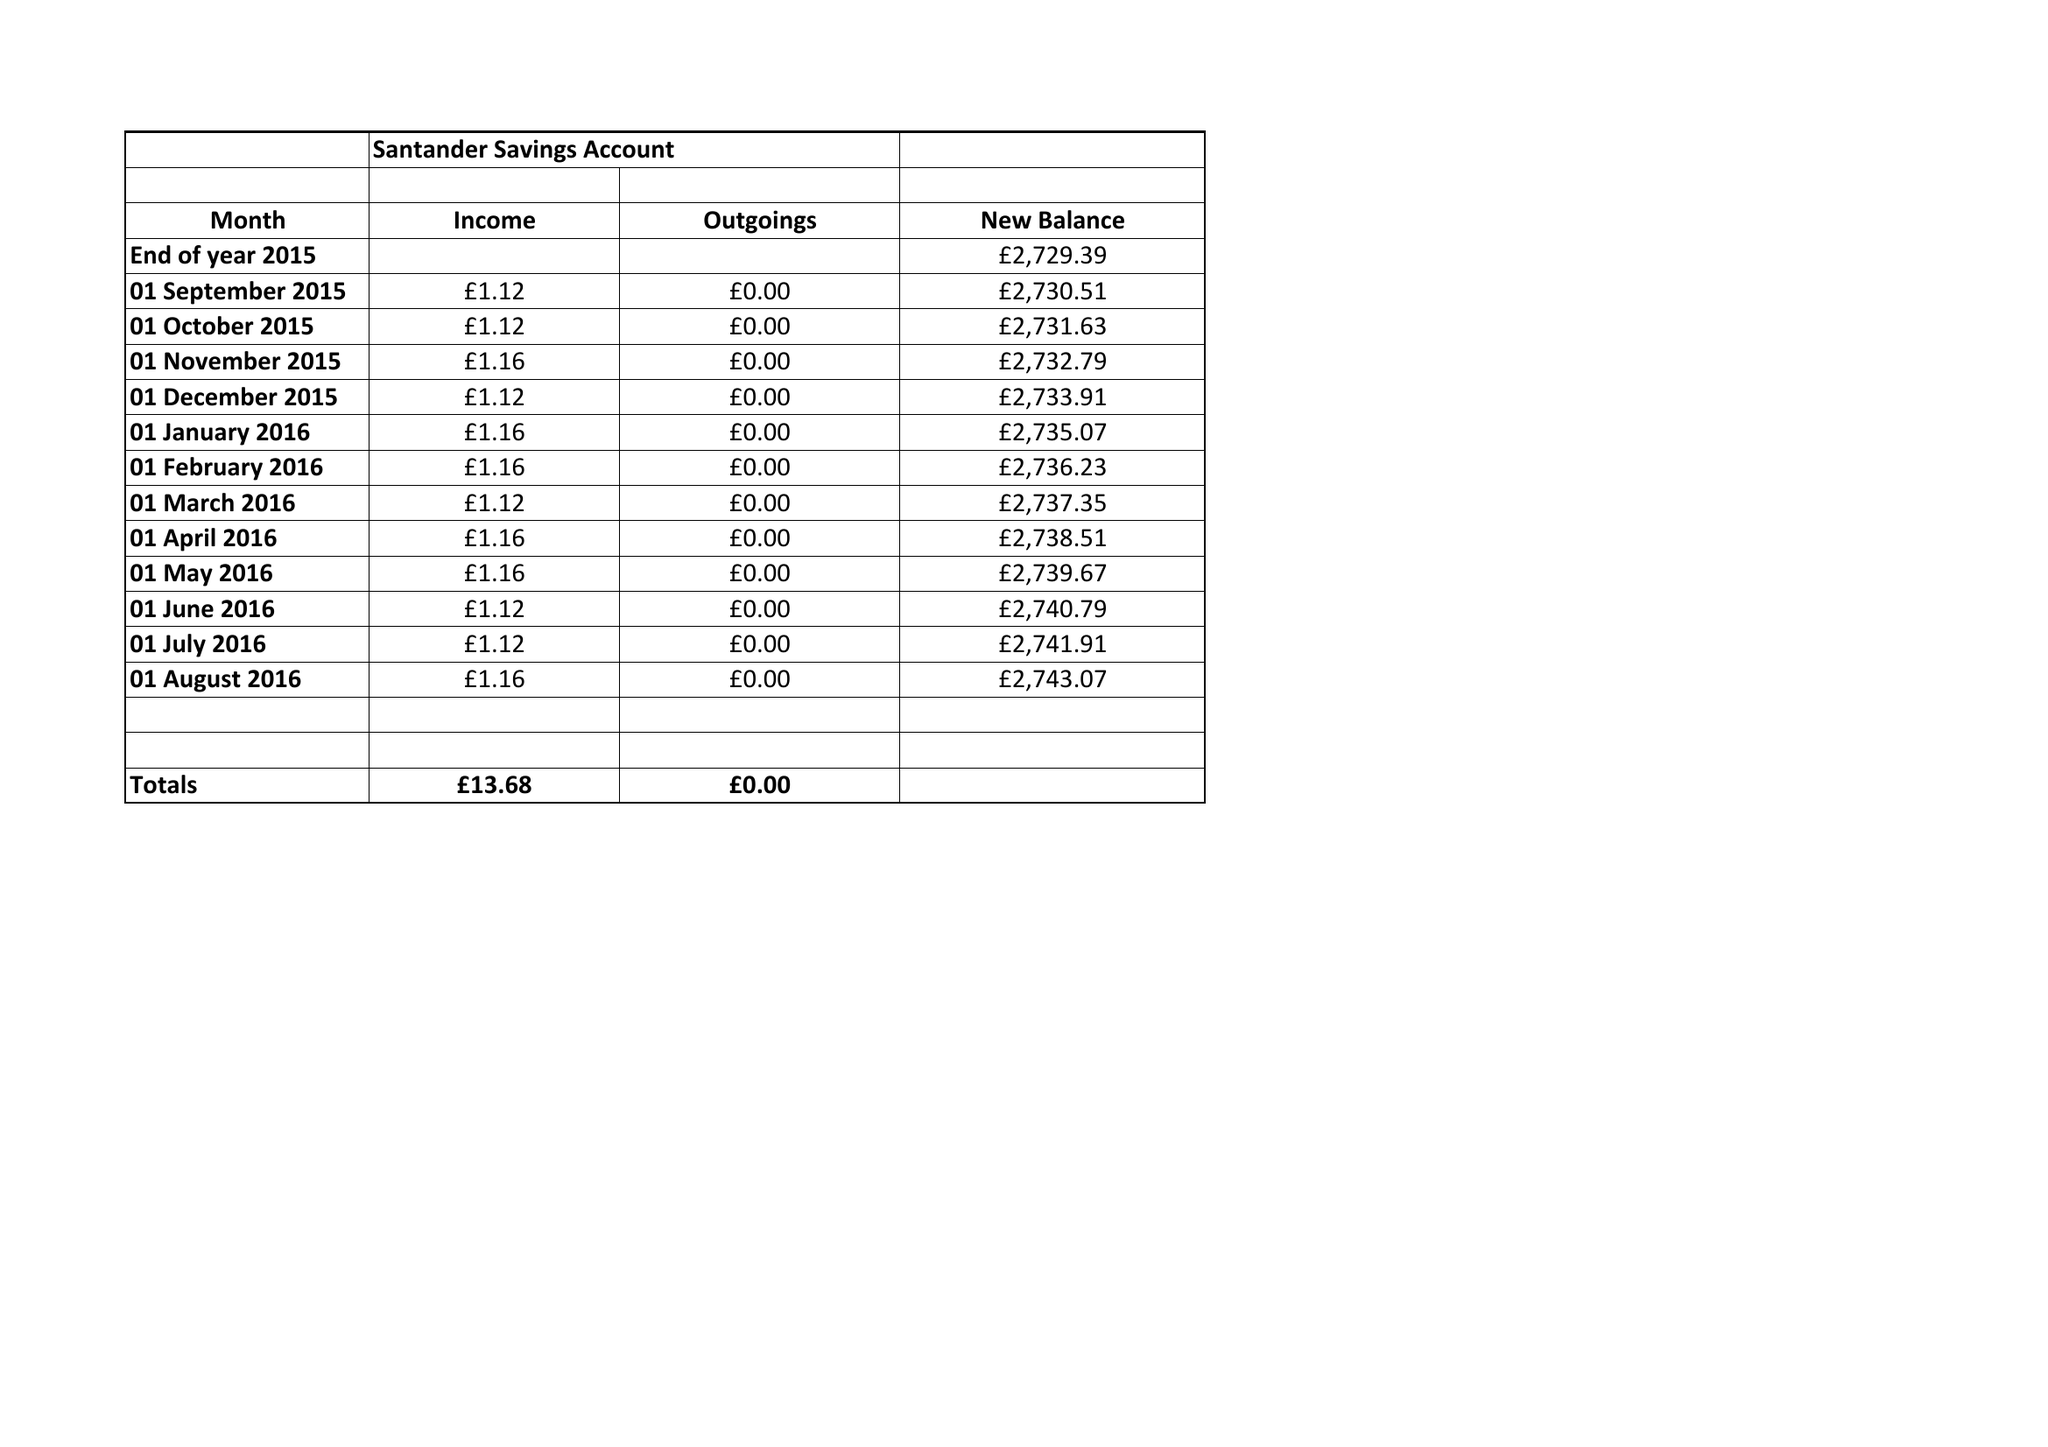What is the value for the address__street_line?
Answer the question using a single word or phrase. None 